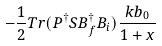Convert formula to latex. <formula><loc_0><loc_0><loc_500><loc_500>- \frac { 1 } { 2 } T r ( P ^ { \dagger } S B ^ { \dagger } _ { f } B _ { i } ) \frac { k b _ { 0 } } { 1 + x }</formula> 